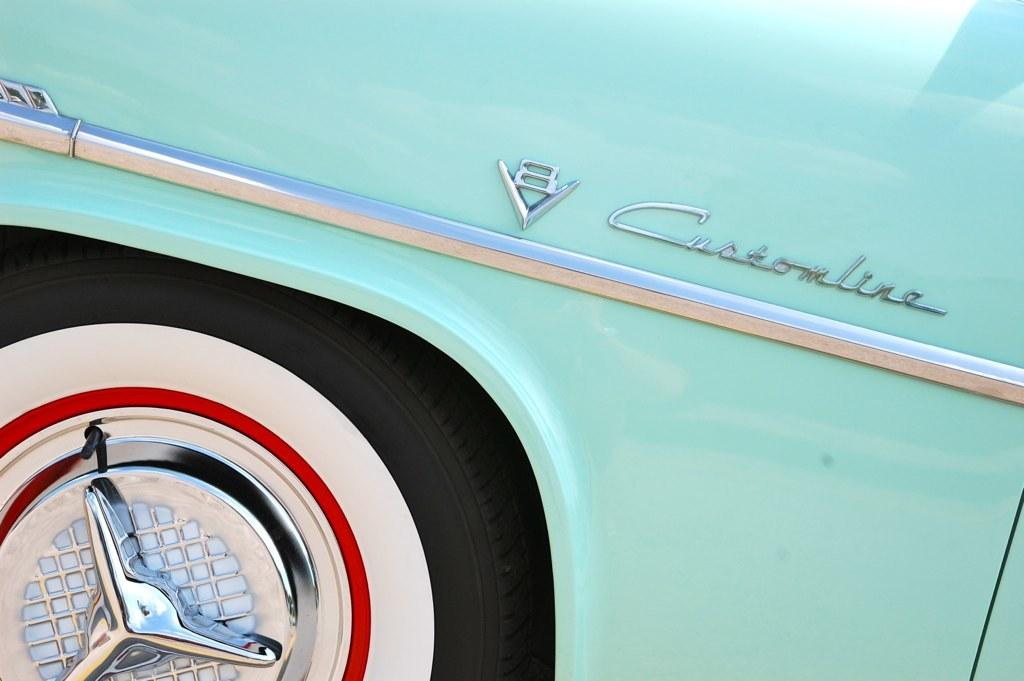What is located in the foreground of the image? There is a vehicle and a tire in the foreground of the image. What can be seen on the vehicle? There is text written on the vehicle. How many frogs are sitting on the spoon in the image? There is no spoon or frogs present in the image. 